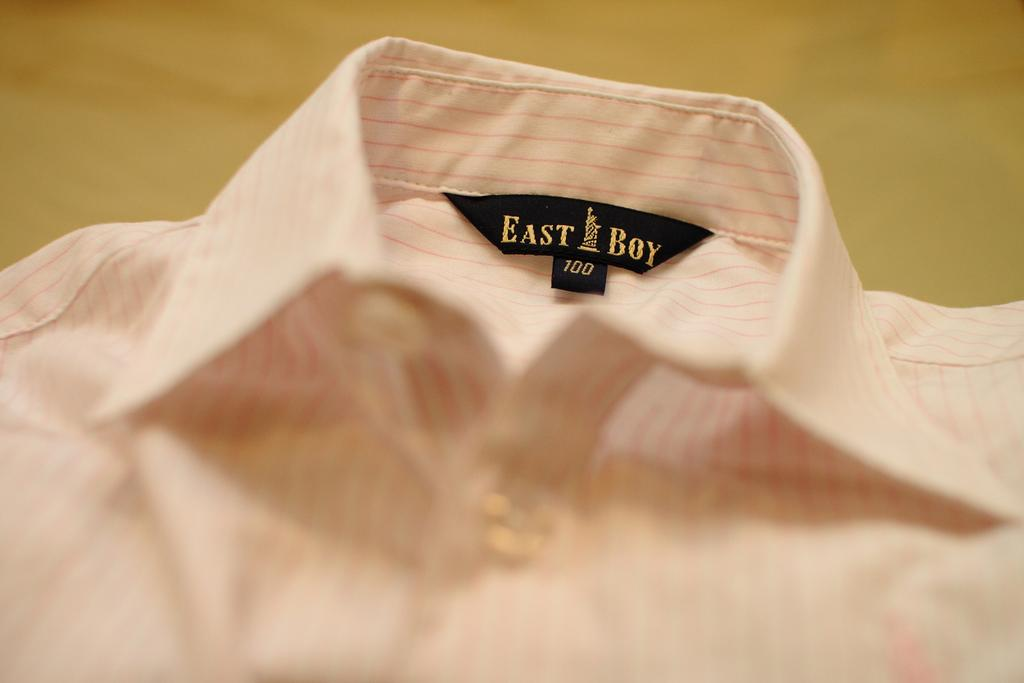What type of shirt is visible in the image? There is a white collar shirt in the image. What design elements are present on the shirt? The shirt has pink color lines on it. Is there any additional detail on the shirt? Yes, there is a black color sticker at the collar of the shirt. How would you describe the background of the image? The background of the image is blurred. What type of end can be seen on the shirt in the image? There is no end visible on the shirt in the image; it is a shirt with a collar and sleeves. What cause might have led to the blurred background in the image? The cause of the blurred background in the image is not mentioned in the provided facts, so it cannot be determined. 